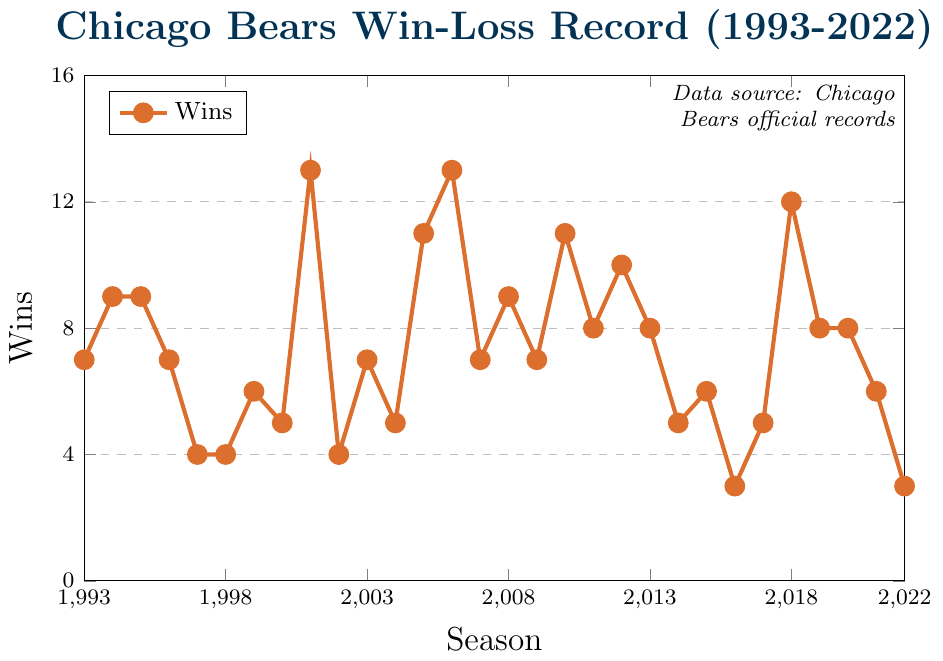what's the highest number of wins achieved in a single season? To find the highest number of wins, look at the peak in the plot. The highest point is at 13 wins, which occurred in 2001 and 2006.
Answer: 13 In which season did the team have the lowest number of wins? To find the lowest number of wins, locate the lowest point on the plot. The lowest point is at 3 wins, which occurred in 2016 and 2022.
Answer: 2016 and 2022 what is the average number of wins over the entire period? Sum up all the wins from each season and divide by the number of seasons. (7+9+9+7+4+4+6+5+13+4+7+5+11+13+7+9+7+11+8+10+8+5+6+3+5+12+8+8+6+3)/30 = 7.13
Answer: 7.13 How many seasons did the team win more games than they lost? Count the number of seasons where wins > losses. From the plot, these are: 1994, 1995, 2001, 2005, 2006, 2008, 2010, 2012, 2018 = 9 seasons.
Answer: 9 How does the win count in 2001 compare to 2022? Look at the win counts for both years on the plot. 2001 has 13 wins whereas 2022 has 3 wins. 13 wins are significantly greater than 3 wins.
Answer: 2001 has 10 more wins than 2022 which season(s) have the same number of wins as 1994? Check the plot for the win count in 1994, which is 9 wins, and find other seasons with the same count. 1995 and 2008 also have 9 wins.
Answer: 1995 and 2008 What is the trend between 1996 and 1999? Look at the plot from 1996 to 1999. Wins decreased from 7 in 1996 to 4 in 1997 and 1998, then slightly increased to 6 in 1999.
Answer: Mostly decreasing, then slightly increasing What's the median number of wins over these seasons? List all the win counts, order them, and find the middle value. Ordered: 3, 3, 4, 4, 4, 5, 5, 5, 5, 6, 6, 7, 7, 7, 7, 7, 8, 8, 8, 8, 9, 9, 9, 10, 11, 11, 12, 13, 13, 13. Median is 7.
Answer: 7 How many times did the team win at least 10 games in a season? Count the number of seasons with win counts >= 10. These seasons are: 2001, 2005, 2006, 2010, 2012, 2018. That’s 6 seasons.
Answer: 6 